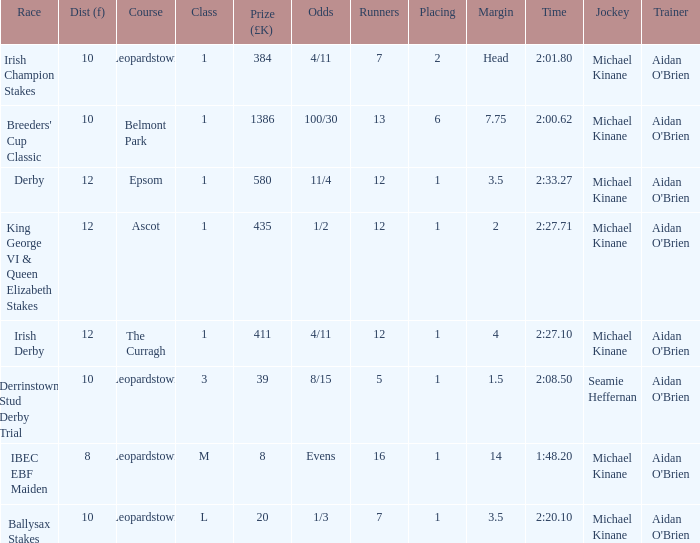Which Margin has a Dist (f) larger than 10, and a Race of king george vi & queen elizabeth stakes? 2.0. 